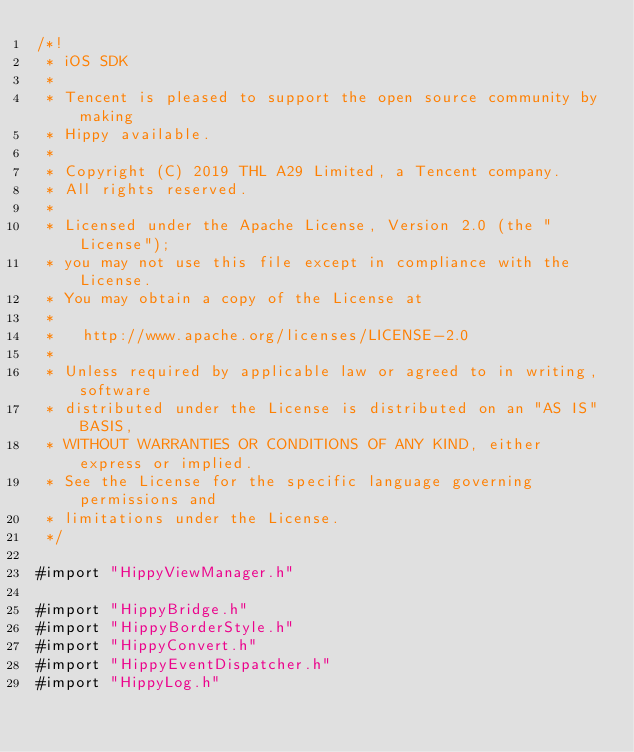Convert code to text. <code><loc_0><loc_0><loc_500><loc_500><_ObjectiveC_>/*!
 * iOS SDK
 *
 * Tencent is pleased to support the open source community by making
 * Hippy available.
 *
 * Copyright (C) 2019 THL A29 Limited, a Tencent company.
 * All rights reserved.
 *
 * Licensed under the Apache License, Version 2.0 (the "License");
 * you may not use this file except in compliance with the License.
 * You may obtain a copy of the License at
 *
 *   http://www.apache.org/licenses/LICENSE-2.0
 *
 * Unless required by applicable law or agreed to in writing, software
 * distributed under the License is distributed on an "AS IS" BASIS,
 * WITHOUT WARRANTIES OR CONDITIONS OF ANY KIND, either express or implied.
 * See the License for the specific language governing permissions and
 * limitations under the License.
 */

#import "HippyViewManager.h"

#import "HippyBridge.h"
#import "HippyBorderStyle.h"
#import "HippyConvert.h"
#import "HippyEventDispatcher.h"
#import "HippyLog.h"</code> 